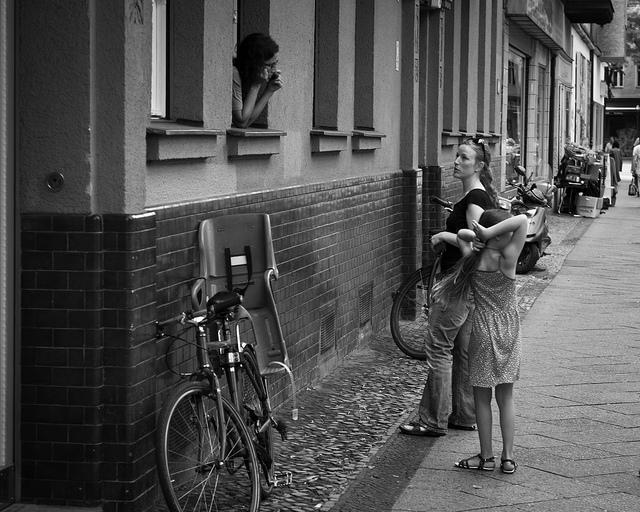How many people can be seen?
Give a very brief answer. 3. How many bicycles are visible?
Give a very brief answer. 2. How many motorcycles are there?
Give a very brief answer. 2. 